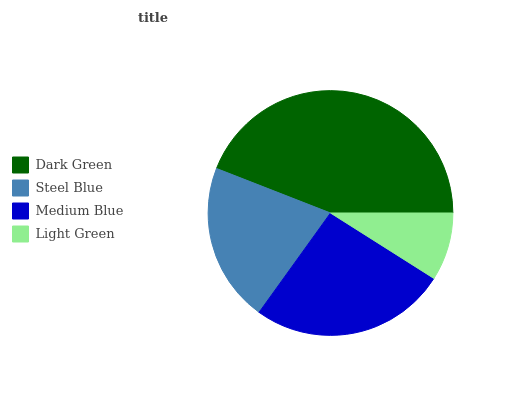Is Light Green the minimum?
Answer yes or no. Yes. Is Dark Green the maximum?
Answer yes or no. Yes. Is Steel Blue the minimum?
Answer yes or no. No. Is Steel Blue the maximum?
Answer yes or no. No. Is Dark Green greater than Steel Blue?
Answer yes or no. Yes. Is Steel Blue less than Dark Green?
Answer yes or no. Yes. Is Steel Blue greater than Dark Green?
Answer yes or no. No. Is Dark Green less than Steel Blue?
Answer yes or no. No. Is Medium Blue the high median?
Answer yes or no. Yes. Is Steel Blue the low median?
Answer yes or no. Yes. Is Light Green the high median?
Answer yes or no. No. Is Medium Blue the low median?
Answer yes or no. No. 